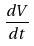<formula> <loc_0><loc_0><loc_500><loc_500>\frac { d V } { d t }</formula> 